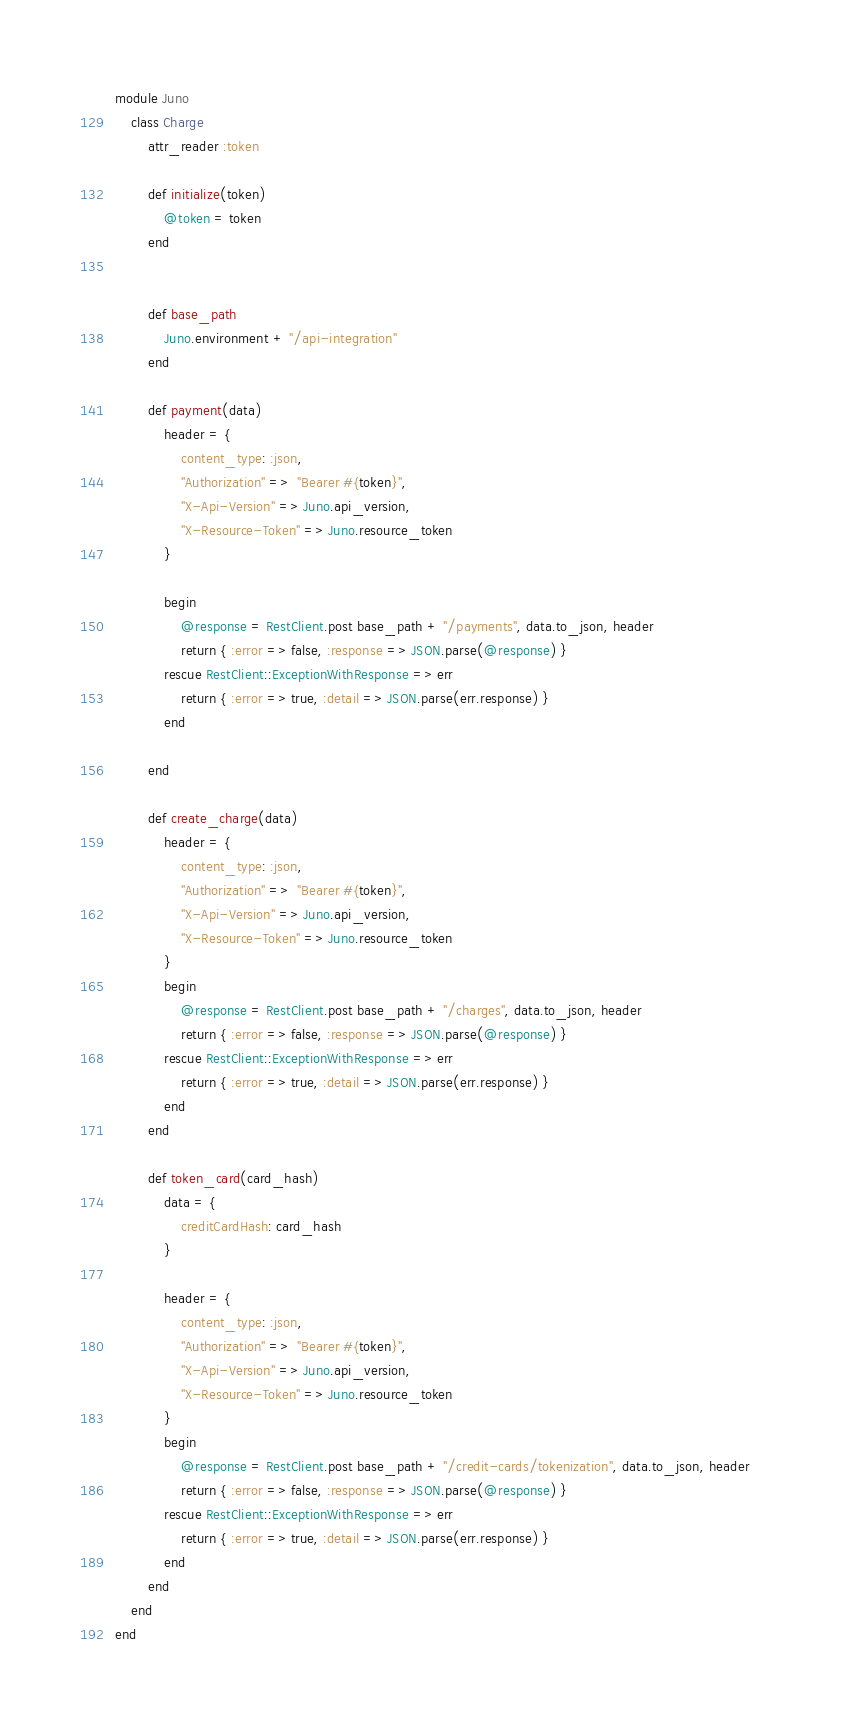Convert code to text. <code><loc_0><loc_0><loc_500><loc_500><_Ruby_>module Juno
    class Charge
        attr_reader :token

        def initialize(token)
            @token = token
        end
        

        def base_path
            Juno.environment + "/api-integration"
        end

        def payment(data)
            header = {
                content_type: :json,
                "Authorization" =>  "Bearer #{token}",
                "X-Api-Version" => Juno.api_version,
                "X-Resource-Token" => Juno.resource_token
            }
          
            begin
                @response = RestClient.post base_path + "/payments", data.to_json, header
                return { :error => false, :response => JSON.parse(@response) }
            rescue RestClient::ExceptionWithResponse => err
                return { :error => true, :detail => JSON.parse(err.response) }
            end        
    
        end

        def create_charge(data)
            header = {
                content_type: :json,
                "Authorization" =>  "Bearer #{token}",
                "X-Api-Version" => Juno.api_version,
                "X-Resource-Token" => Juno.resource_token
            }
            begin
                @response = RestClient.post base_path + "/charges", data.to_json, header 
                return { :error => false, :response => JSON.parse(@response) }
            rescue RestClient::ExceptionWithResponse => err
                return { :error => true, :detail => JSON.parse(err.response) }                
            end                       
        end

        def token_card(card_hash)   
            data = {
                creditCardHash: card_hash
            }

            header = {
                content_type: :json,
                "Authorization" =>  "Bearer #{token}",
                "X-Api-Version" => Juno.api_version,
                "X-Resource-Token" => Juno.resource_token
            }
            begin
                @response = RestClient.post base_path + "/credit-cards/tokenization", data.to_json, header     
                return { :error => false, :response => JSON.parse(@response) }
            rescue RestClient::ExceptionWithResponse => err 
                return { :error => true, :detail => JSON.parse(err.response) }                
            end  
        end
    end    
end</code> 